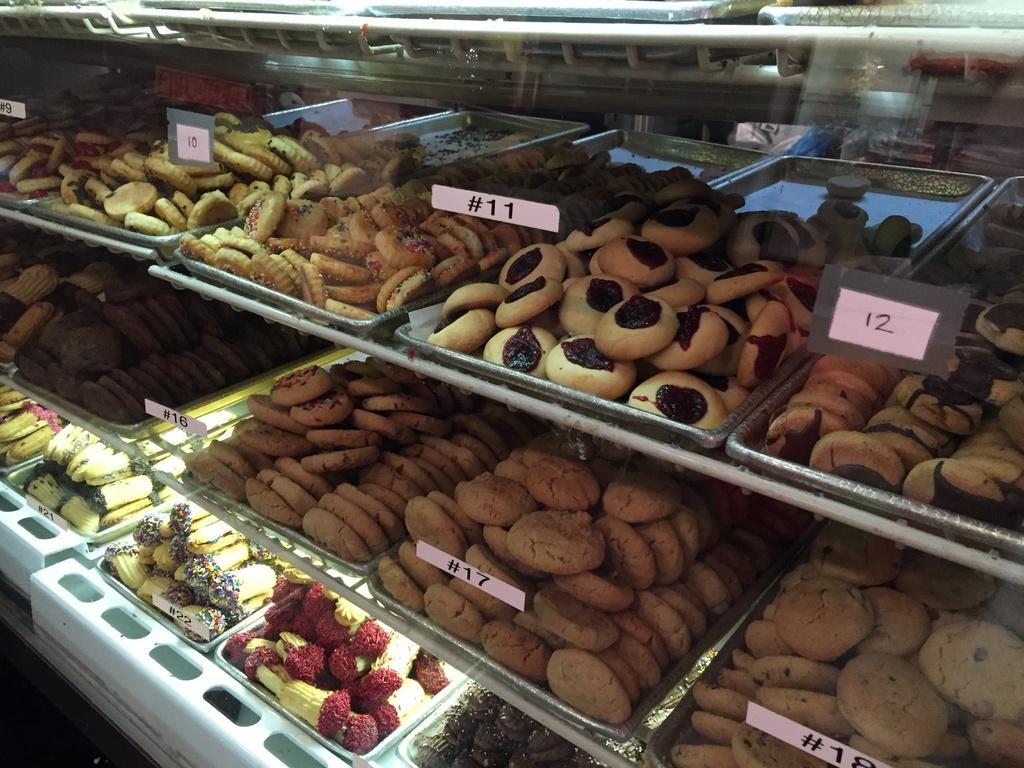Could you give a brief overview of what you see in this image? In this image we can see trays on racks. On the trays there are snacks. Also there are tags. 